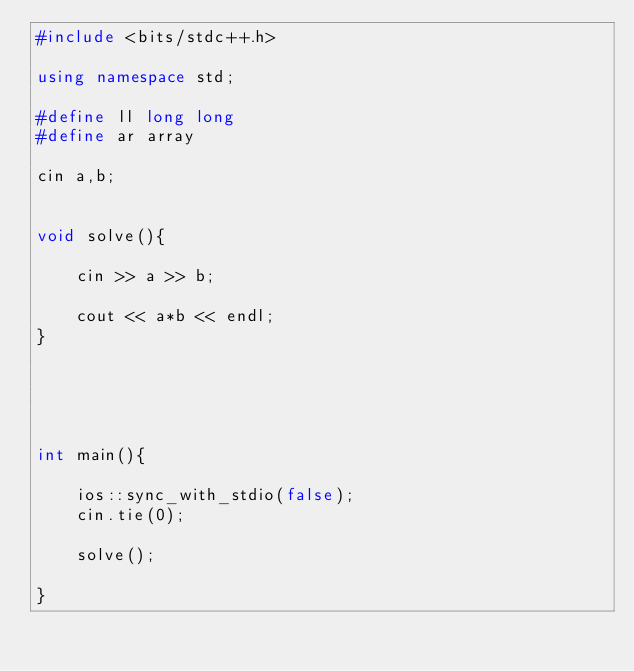Convert code to text. <code><loc_0><loc_0><loc_500><loc_500><_C++_>#include <bits/stdc++.h>

using namespace std;

#define ll long long
#define ar array

cin a,b;


void solve(){

    cin >> a >> b;

    cout << a*b << endl;
}





int main(){

    ios::sync_with_stdio(false);
    cin.tie(0);

    solve();

}</code> 